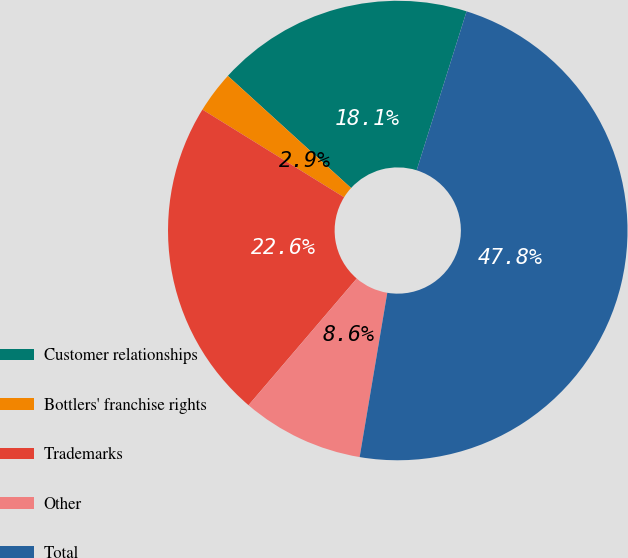Convert chart to OTSL. <chart><loc_0><loc_0><loc_500><loc_500><pie_chart><fcel>Customer relationships<fcel>Bottlers' franchise rights<fcel>Trademarks<fcel>Other<fcel>Total<nl><fcel>18.09%<fcel>2.93%<fcel>22.57%<fcel>8.6%<fcel>47.81%<nl></chart> 